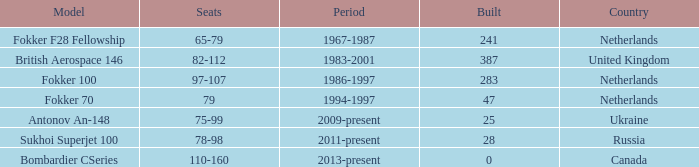Between which years were there 241 fokker 70 model cabins built? 1994-1997. 